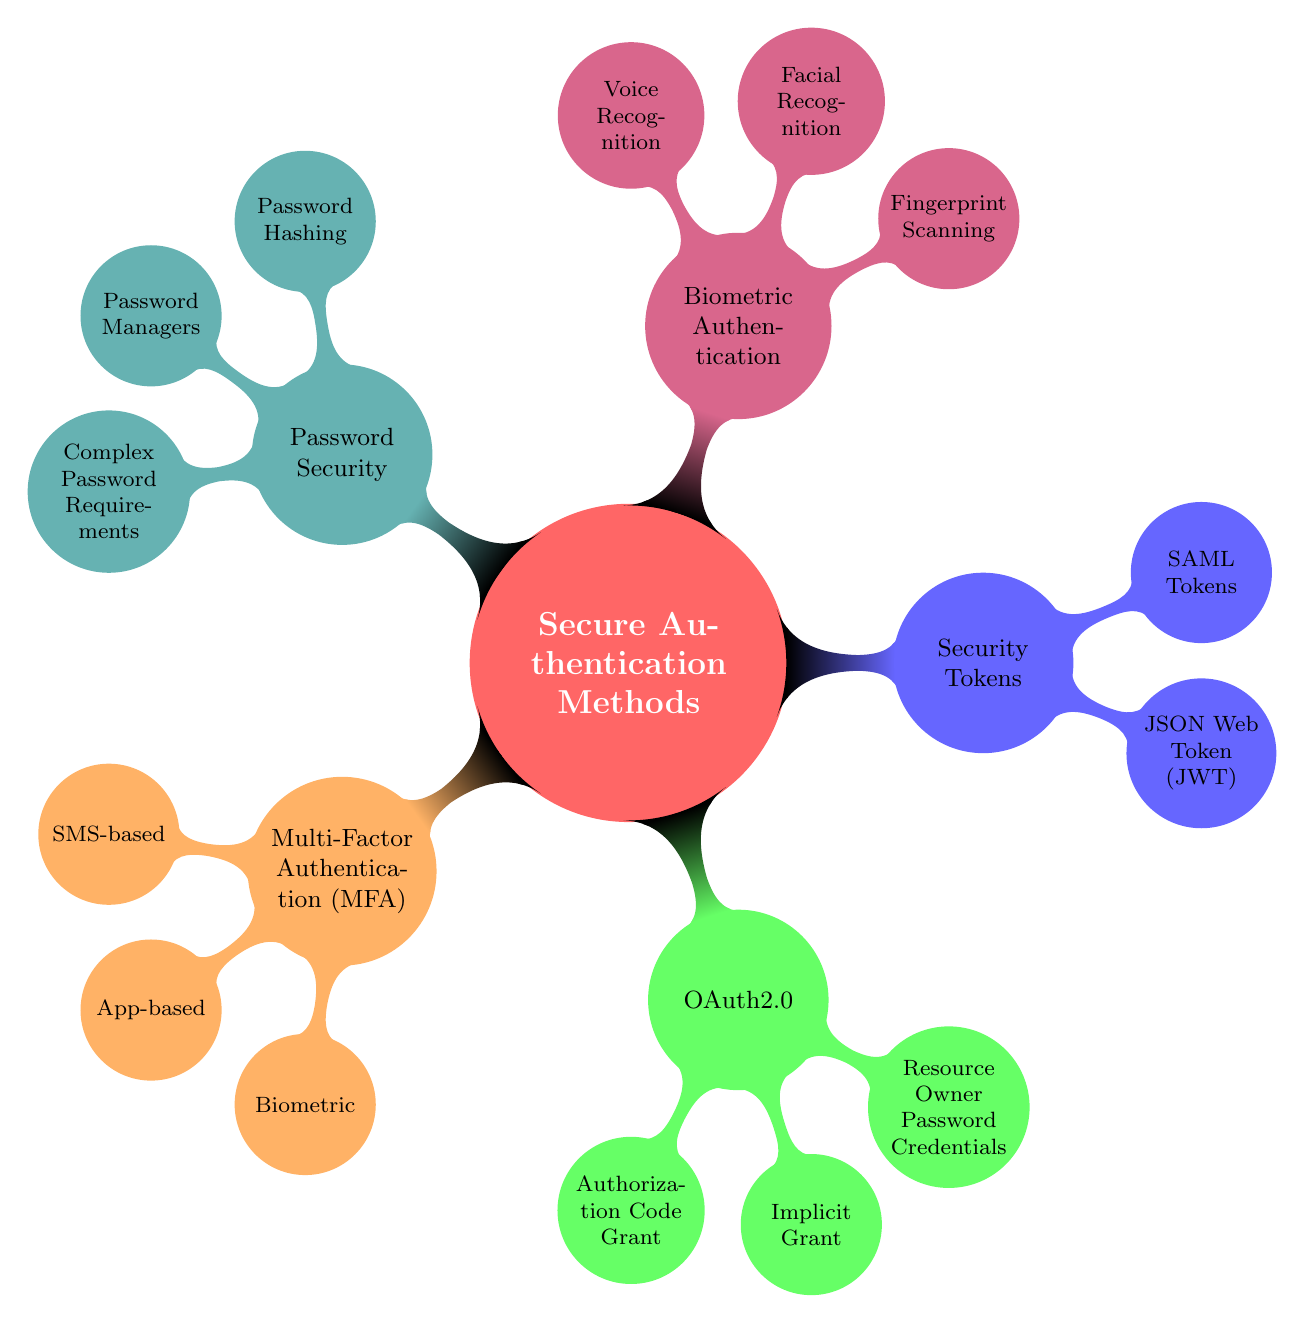What is a form of Multi-Factor Authentication? The diagram lists "SMS-based", "App-based", and "Biometric" under Multi-Factor Authentication (MFA). Each of these is a different approach to implementing MFA, providing multiple ways for users to verify their identities.
Answer: SMS-based How many components are listed under OAuth2.0? The diagram shows three components under OAuth2.0: "Authorization Code Grant", "Implicit Grant", and "Resource Owner Password Credentials". Counting these three components gives the total.
Answer: 3 What type of token is self-contained? "JSON Web Token (JWT)" is specified as the type of token that is self-contained. It includes all the relevant data needed for authentication within the token itself.
Answer: JSON Web Token Which authentication method uses voice patterns? Under "Biometric Authentication", "Voice Recognition" is listed as the method that uses voice patterns for user verification. This is a specific type of biometric authentication focused on the user's voice.
Answer: Voice Recognition What are the practices for password security? The diagram lists three practices under Password Security: "Password Hashing", "Password Managers", and "Complex Password Requirements". All these practices aim to enhance the security of passwords.
Answer: Password Hashing, Password Managers, Complex Password Requirements What is used primarily in enterprise settings for Single Sign-On? "SAML Tokens" are specified as the method that is primarily used in enterprise settings for Single Sign-On (SSO), making it relevant in organizational contexts.
Answer: SAML Tokens Which two types fall under Biometric Authentication? The diagram indicates "Fingerprint Scanning" and "Facial Recognition" as two types of Biometric Authentication. Both represent different means of verifying identity using biometric data.
Answer: Fingerprint Scanning, Facial Recognition How does Multi-Factor Authentication enhance security? Multi-Factor Authentication enhances security by requiring two or more verification methods, making unauthorized access significantly more difficult without the multiple factors of verification.
Answer: More verification methods What does the resource owner password credentials utilize? The diagram specifies that "Resource Owner Password Credentials" directly uses user credentials, indicating it requires the username/password combination directly from the user.
Answer: User credentials 